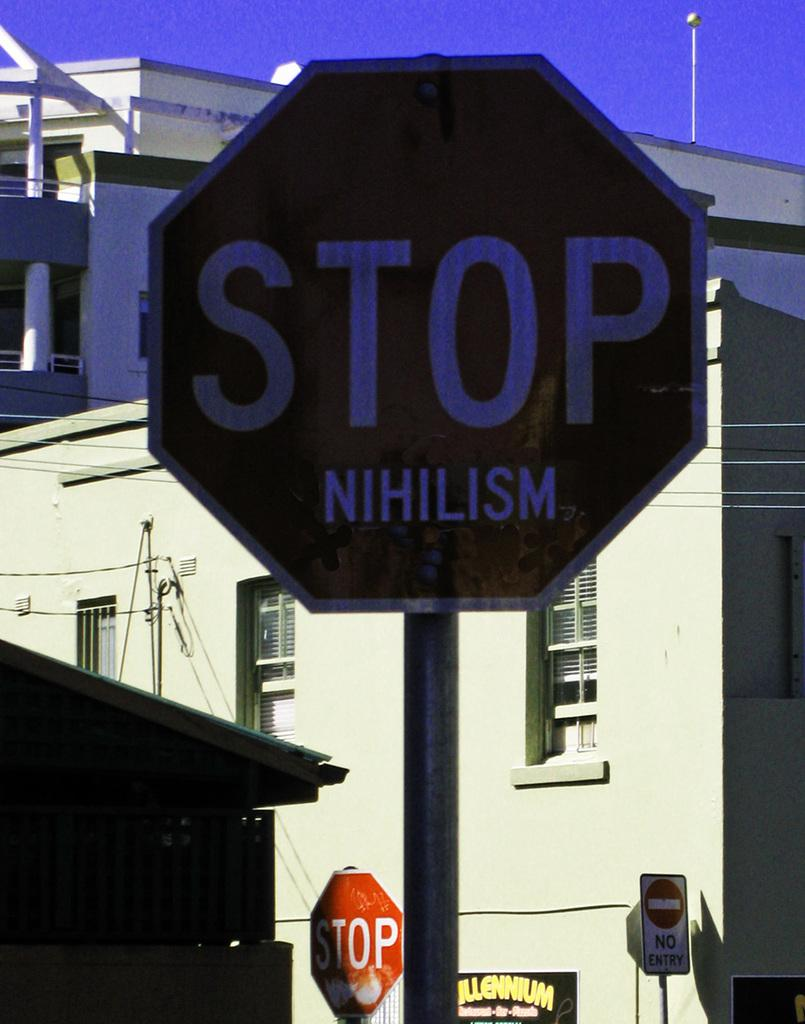<image>
Summarize the visual content of the image. A red and white sign that says stop has a sticker that reads nihilism on the bottom of it. 